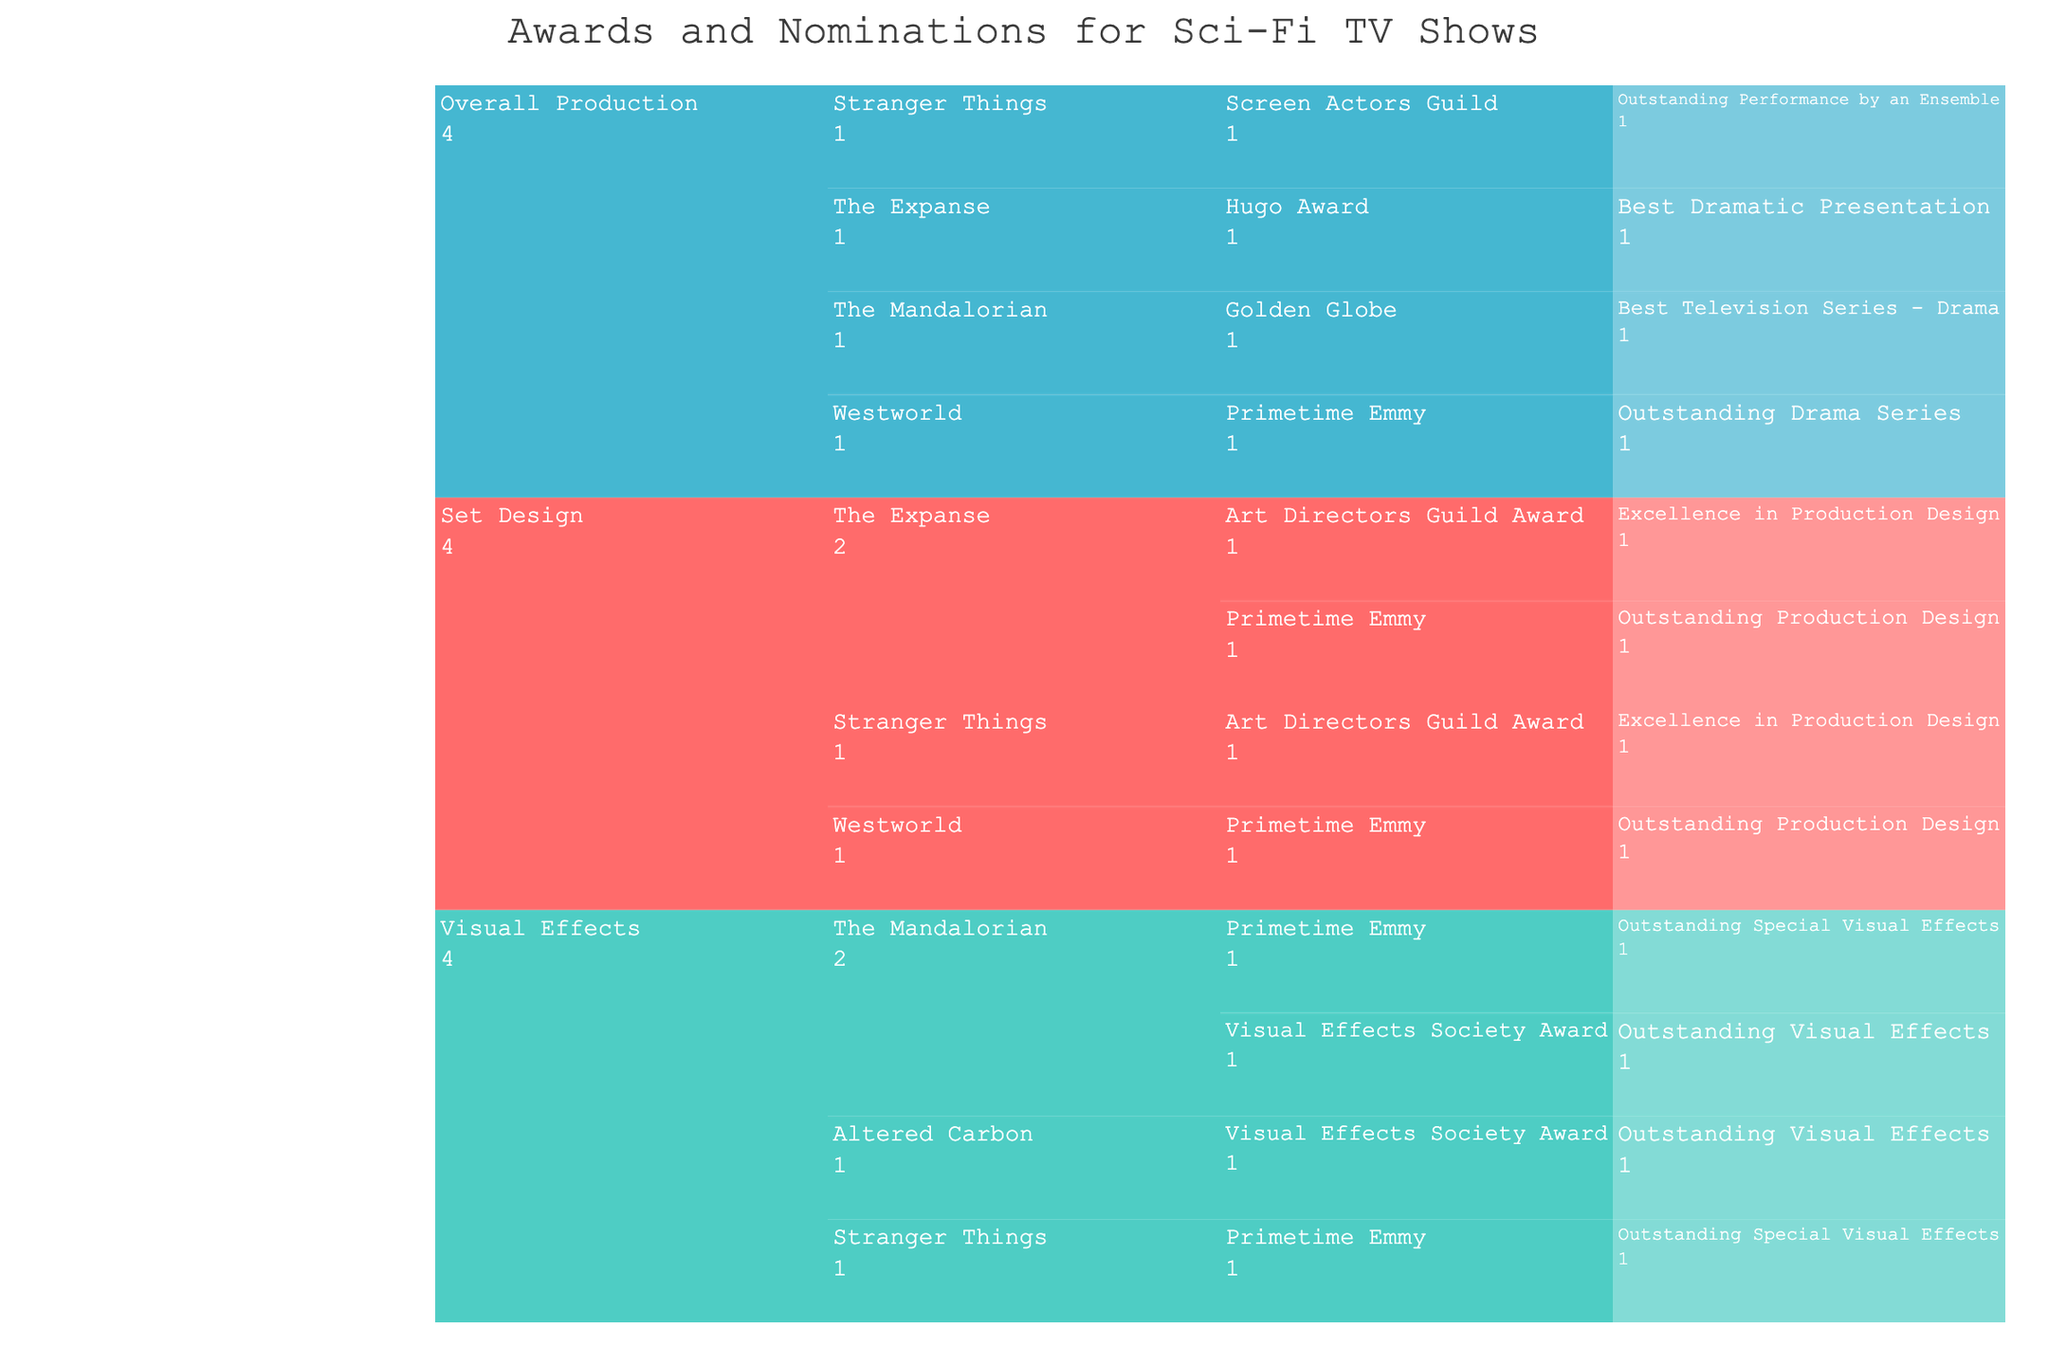What category has the highest number of awards? Look at the highest level of the icicle chart, and identify which category has the largest area.
Answer: Overall Production Which show under the 'Set Design' category has the most awards? Identify the 'Set Design' category, then compare the areas of its subcategories to see which show encompasses the largest area.
Answer: The Expanse How many awards did 'Stranger Things' receive in the 'Visual Effects' category? Navigate to the 'Visual Effects' category and find the area representing 'Stranger Things', then count the number of subcategories (awards) under it.
Answer: 1 Compare 'The Mandalorian' and 'Stranger Things': which has more awards in total across all categories? Add the areas representing 'The Mandalorian' and 'Stranger Things' in every category, then compare the totals.
Answer: The Mandalorian Which award type appears most frequently in the dataset? Look at all levels of the icicle chart and count the occurrence of each award type to determine which one appears the most.
Answer: Primetime Emmy How many shows have received a 'Primetime Emmy' award? Locate the branches for 'Primetime Emmy' and count the number of distinct shows under it across all categories.
Answer: 3 Under the 'Overall Production' category, which show received the 'Golden Globe' award? Navigate to the 'Overall Production' category, find 'Golden Globe', and determine which show is directly under it.
Answer: The Mandalorian What is the total number of awards received by 'Westworld' across all categories? Identify all occurrences of 'Westworld' in the icicle chart, then sum the number of its awards across all categories.
Answer: 2 Which category has the least number of shows? Compare the number of distinct shows under each main category to find the one with the least.
Answer: Visual Effects Which category and show combination has the 'Hugo Award'? Room in on the specific branches of the icicle chart that represent the 'Hugo Award' to determine its location.
Answer: Overall Production, The Expanse 